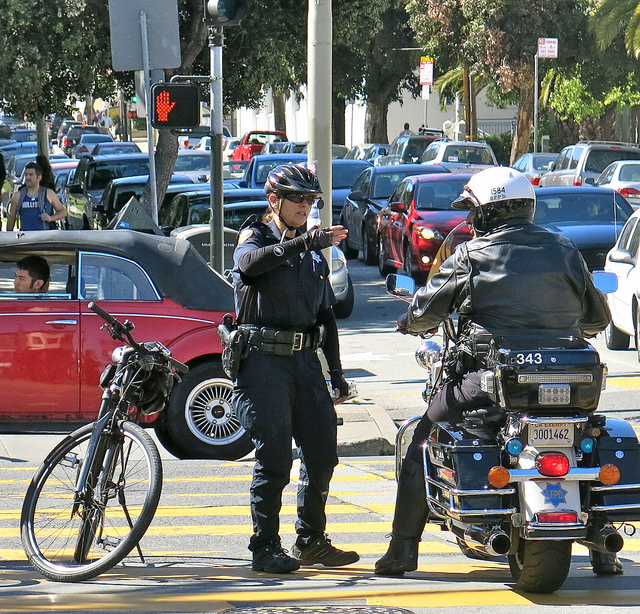Can you describe what's happening in this scene? In the image, two police officers on duty appear to be having a conversation by the roadside. One officer is gesturing, perhaps explaining a scenario or giving directions, while the other is attentively listening. There is a motorcycle parked on the road, which suggests they might be motorcycle patrol officers. Traffic can be seen in the background, indicating they could be discussing traffic-related issues or strategizing about their patrol. 